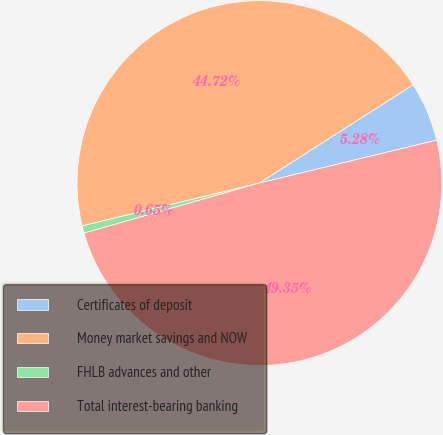Convert chart to OTSL. <chart><loc_0><loc_0><loc_500><loc_500><pie_chart><fcel>Certificates of deposit<fcel>Money market savings and NOW<fcel>FHLB advances and other<fcel>Total interest-bearing banking<nl><fcel>5.28%<fcel>44.72%<fcel>0.65%<fcel>49.35%<nl></chart> 